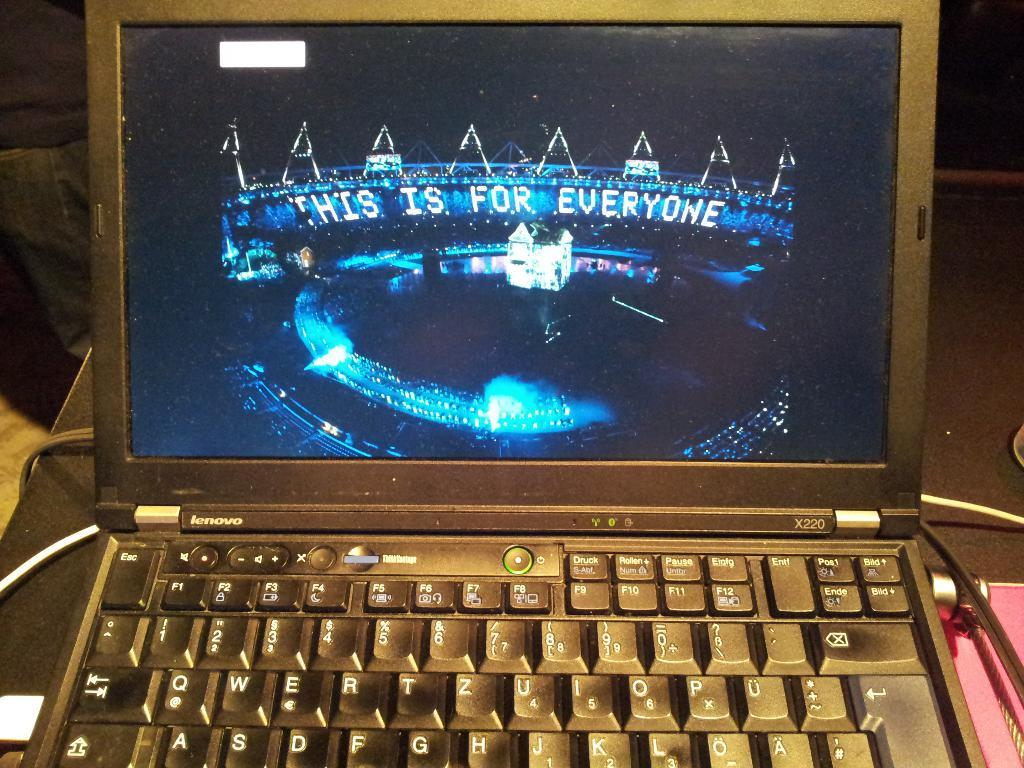<image>
Relay a brief, clear account of the picture shown. a laptop with the word Lenovo on the front 